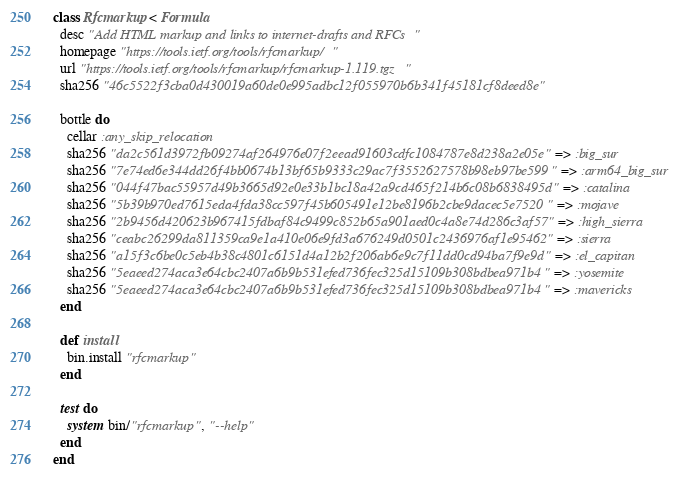<code> <loc_0><loc_0><loc_500><loc_500><_Ruby_>class Rfcmarkup < Formula
  desc "Add HTML markup and links to internet-drafts and RFCs"
  homepage "https://tools.ietf.org/tools/rfcmarkup/"
  url "https://tools.ietf.org/tools/rfcmarkup/rfcmarkup-1.119.tgz"
  sha256 "46c5522f3cba0d430019a60de0e995adbc12f055970b6b341f45181cf8deed8e"

  bottle do
    cellar :any_skip_relocation
    sha256 "da2c561d3972fb09274af264976e07f2eead91603cdfc1084787e8d238a2e05e" => :big_sur
    sha256 "7e74ed6e344dd26f4bb0674b13bf65b9333c29ac7f3552627578b98eb97be599" => :arm64_big_sur
    sha256 "044f47bac55957d49b3665d92e0e33b1bc18a42a9cd465f214b6c08b6838495d" => :catalina
    sha256 "5b39b970ed7615eda4fda38cc597f45b605491e12be8196b2cbe9dacec5e7520" => :mojave
    sha256 "2b9456d420623b967415fdbaf84c9499c852b65a901aed0c4a8e74d286c3af57" => :high_sierra
    sha256 "ceabc26299da811359ca9e1a410e06e9fd3a676249d0501c2436976af1e95462" => :sierra
    sha256 "a15f3c6be0c5eb4b38c4801c6151d4a12b2f206ab6e9c7f11dd0cd94ba7f9e9d" => :el_capitan
    sha256 "5eaeed274aca3e64cbc2407a6b9b531efed736fec325d15109b308bdbea971b4" => :yosemite
    sha256 "5eaeed274aca3e64cbc2407a6b9b531efed736fec325d15109b308bdbea971b4" => :mavericks
  end

  def install
    bin.install "rfcmarkup"
  end

  test do
    system bin/"rfcmarkup", "--help"
  end
end
</code> 